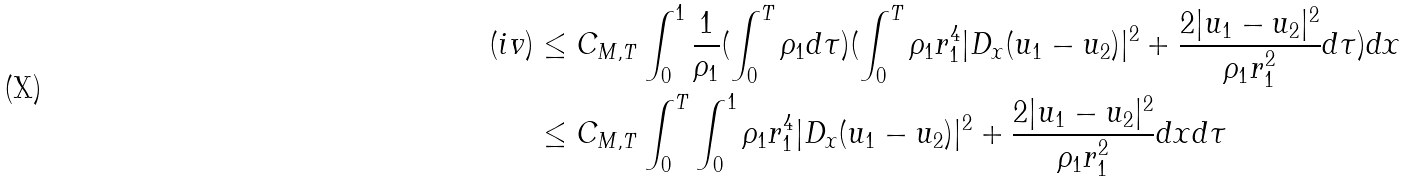Convert formula to latex. <formula><loc_0><loc_0><loc_500><loc_500>( i v ) & \leq C _ { M , T } \int _ { 0 } ^ { 1 } \frac { 1 } { \rho _ { 1 } } ( \int _ { 0 } ^ { T } \rho _ { 1 } d \tau ) ( \int _ { 0 } ^ { T } \rho _ { 1 } r _ { 1 } ^ { 4 } | D _ { x } ( u _ { 1 } - u _ { 2 } ) | ^ { 2 } + \frac { 2 | u _ { 1 } - u _ { 2 } | ^ { 2 } } { \rho _ { 1 } r _ { 1 } ^ { 2 } } d \tau ) d x \\ & \leq C _ { M , T } \int _ { 0 } ^ { T } \int _ { 0 } ^ { 1 } \rho _ { 1 } r _ { 1 } ^ { 4 } | D _ { x } ( u _ { 1 } - u _ { 2 } ) | ^ { 2 } + \frac { 2 | u _ { 1 } - u _ { 2 } | ^ { 2 } } { \rho _ { 1 } r _ { 1 } ^ { 2 } } d x d \tau</formula> 